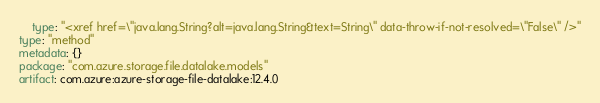<code> <loc_0><loc_0><loc_500><loc_500><_YAML_>    type: "<xref href=\"java.lang.String?alt=java.lang.String&text=String\" data-throw-if-not-resolved=\"False\" />"
type: "method"
metadata: {}
package: "com.azure.storage.file.datalake.models"
artifact: com.azure:azure-storage-file-datalake:12.4.0
</code> 